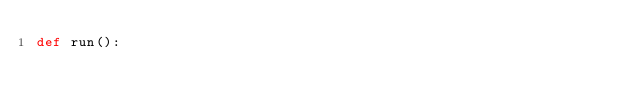<code> <loc_0><loc_0><loc_500><loc_500><_Python_>def run():
	
</code> 